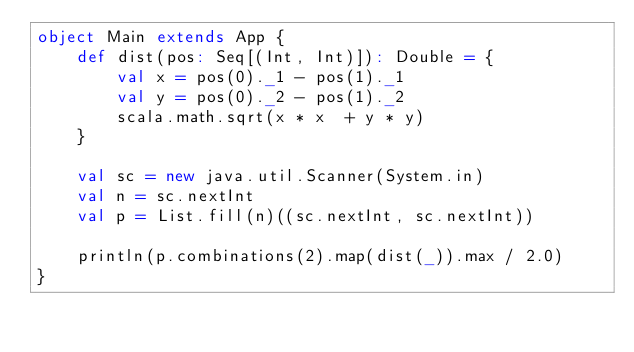<code> <loc_0><loc_0><loc_500><loc_500><_Scala_>object Main extends App {
	def dist(pos: Seq[(Int, Int)]): Double = {
		val x = pos(0)._1 - pos(1)._1
		val y = pos(0)._2 - pos(1)._2
		scala.math.sqrt(x * x  + y * y)
	}
	
	val sc = new java.util.Scanner(System.in)
	val n = sc.nextInt
	val p = List.fill(n)((sc.nextInt, sc.nextInt))
	
	println(p.combinations(2).map(dist(_)).max / 2.0)
}</code> 